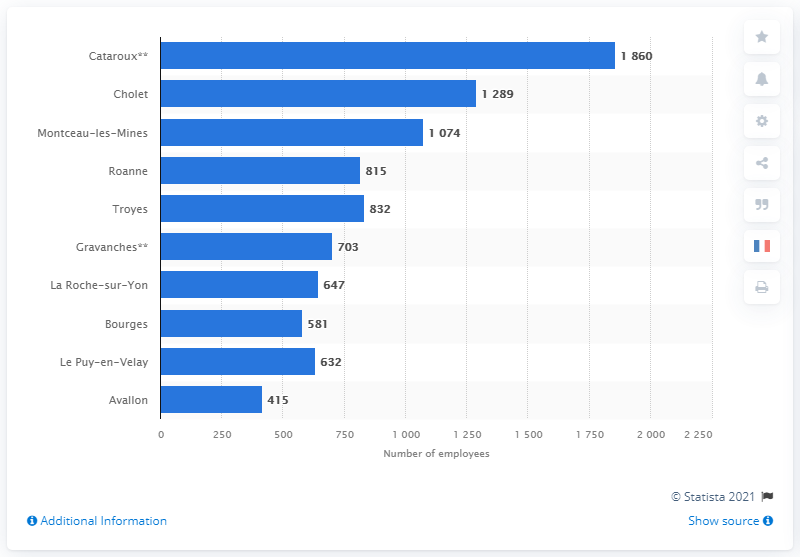Indicate a few pertinent items in this graphic. The main manufacturing site in France is Cholet. 